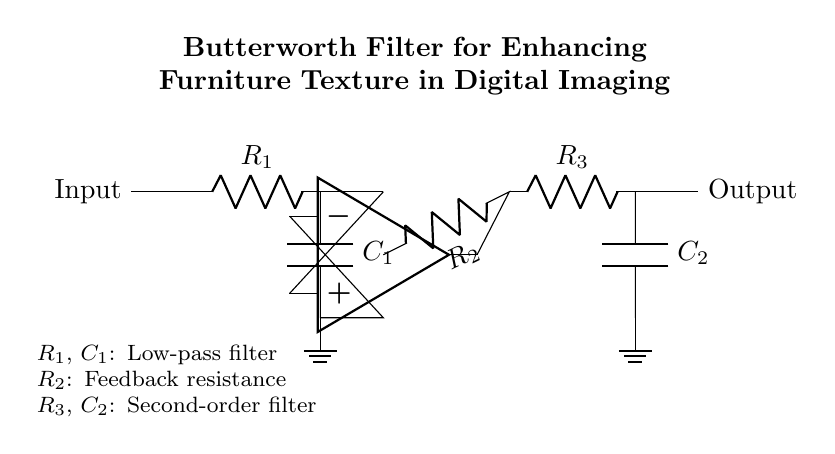What is the type of filter shown in the circuit? The circuit represents a Butterworth filter, known for its flat frequency response and being maximally flat in the passband. It is designed to eliminate high-frequency noise while preserving details in the lower frequency range relevant to the texture of furniture.
Answer: Butterworth filter What are the components used in the first stage of the circuit? The first stage consists of a resistor and a capacitor, specifically named R1 and C1, which work together to form a low-pass filter that allows low-frequency signals to pass while attenuating higher frequencies.
Answer: R1, C1 What is the function of R2 in the circuit? R2 acts as a feedback resistance, modifying the gain of the operational amplifier in the filter circuit, which is crucial for stabilizing the signal and determining the filter's characteristics.
Answer: Feedback resistance How many stages are in the Butterworth filter circuit? There are two stages in the circuit; the first stage includes R1 and C1, and the second stage includes R3 and C2. Each stage contributes to the filtering effect, enhancing the signal processing for clearer texture representation in images.
Answer: Two What is the significance of the ground in this circuit? The ground provides a reference point for the circuit, ensuring a common return path for electric current. It stabilizes the voltage levels in the circuit and is essential for the proper operation of the components, particularly the operational amplifier.
Answer: Reference point What is the role of the capacitor in the filter circuit? Capacitors in a filter circuit, like C1 and C2, block low-frequency signals while allowing higher frequencies to pass through, or vice versa depending on their configuration. In this Butterworth filter, they help smooth the signals to improve clarity in capturing furniture textures.
Answer: Block low-frequency signals 